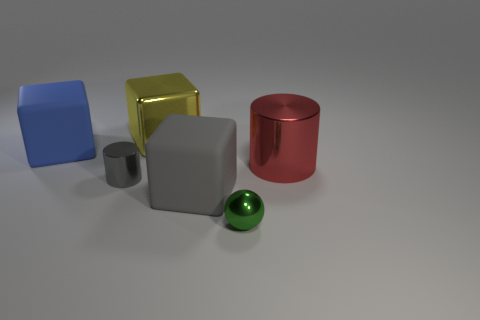Subtract all gray blocks. How many blocks are left? 2 Add 3 small green metal blocks. How many objects exist? 9 Subtract all cylinders. How many objects are left? 4 Subtract all purple cubes. Subtract all purple cylinders. How many cubes are left? 3 Add 6 small gray metallic cylinders. How many small gray metallic cylinders are left? 7 Add 4 cyan matte cubes. How many cyan matte cubes exist? 4 Subtract 0 yellow spheres. How many objects are left? 6 Subtract all large cyan objects. Subtract all large yellow objects. How many objects are left? 5 